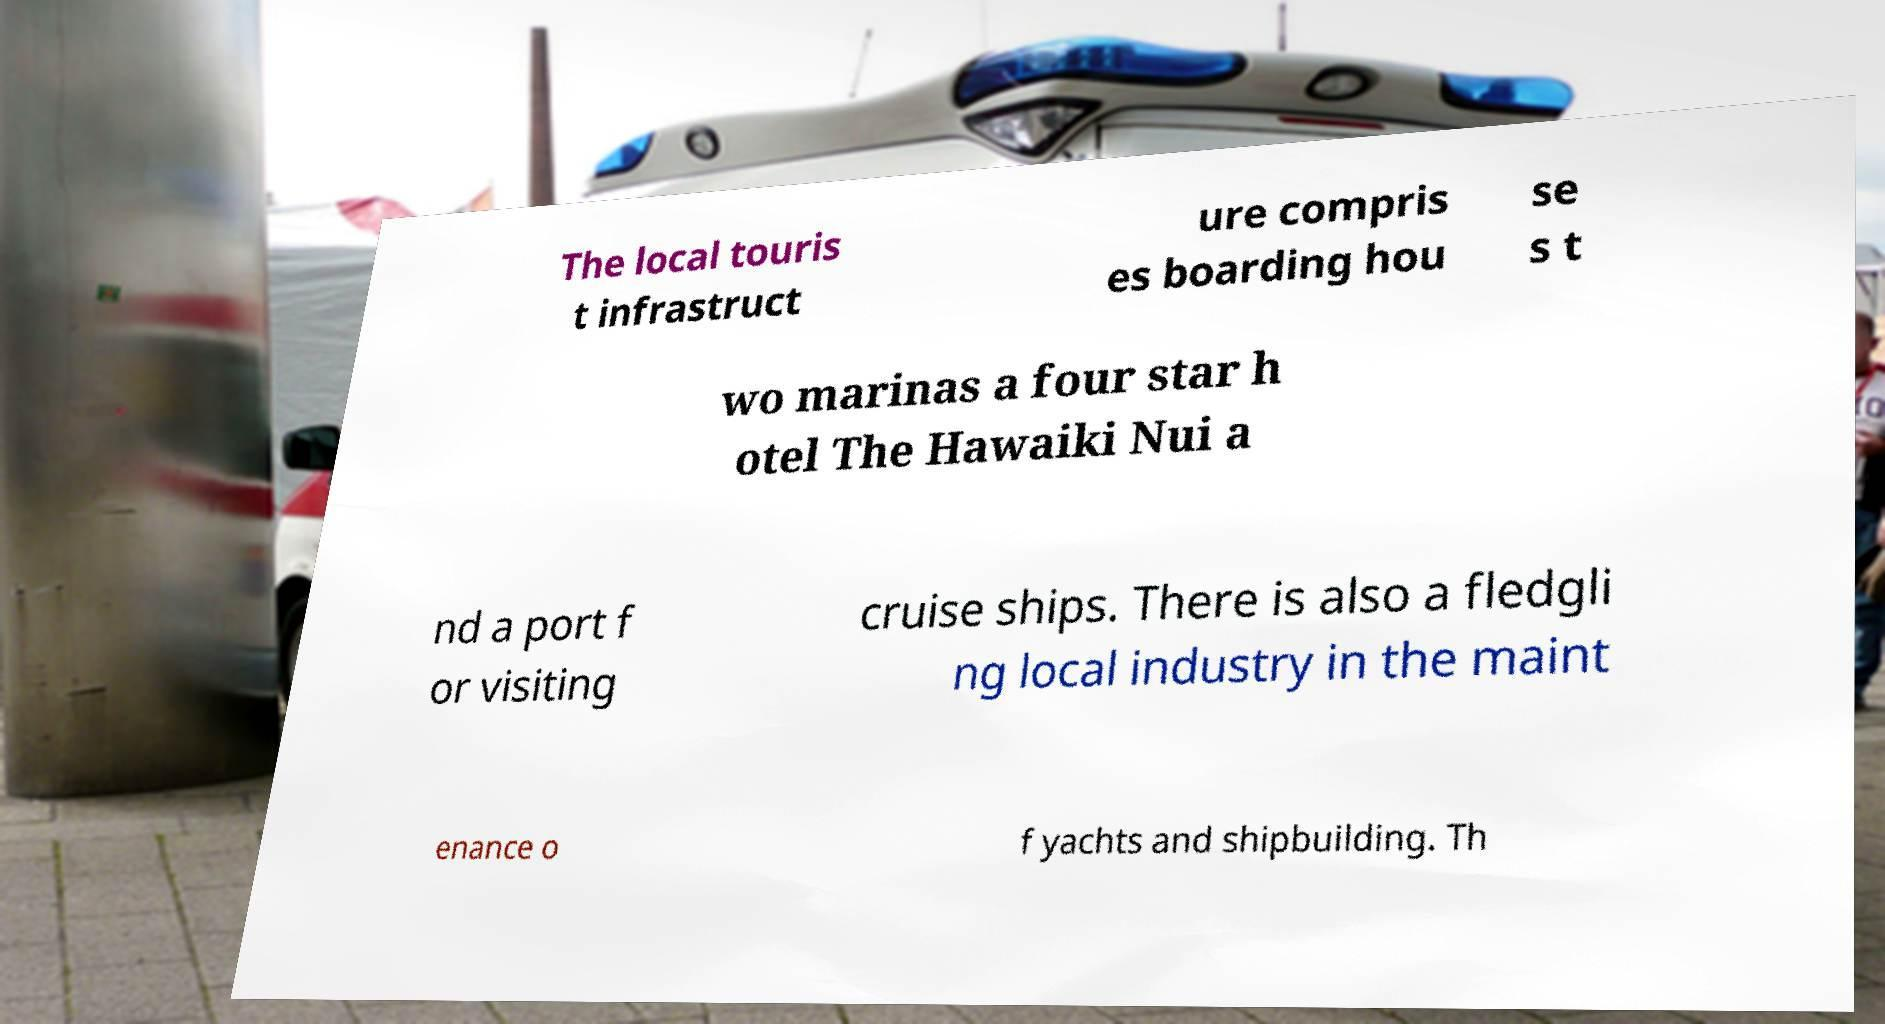I need the written content from this picture converted into text. Can you do that? The local touris t infrastruct ure compris es boarding hou se s t wo marinas a four star h otel The Hawaiki Nui a nd a port f or visiting cruise ships. There is also a fledgli ng local industry in the maint enance o f yachts and shipbuilding. Th 